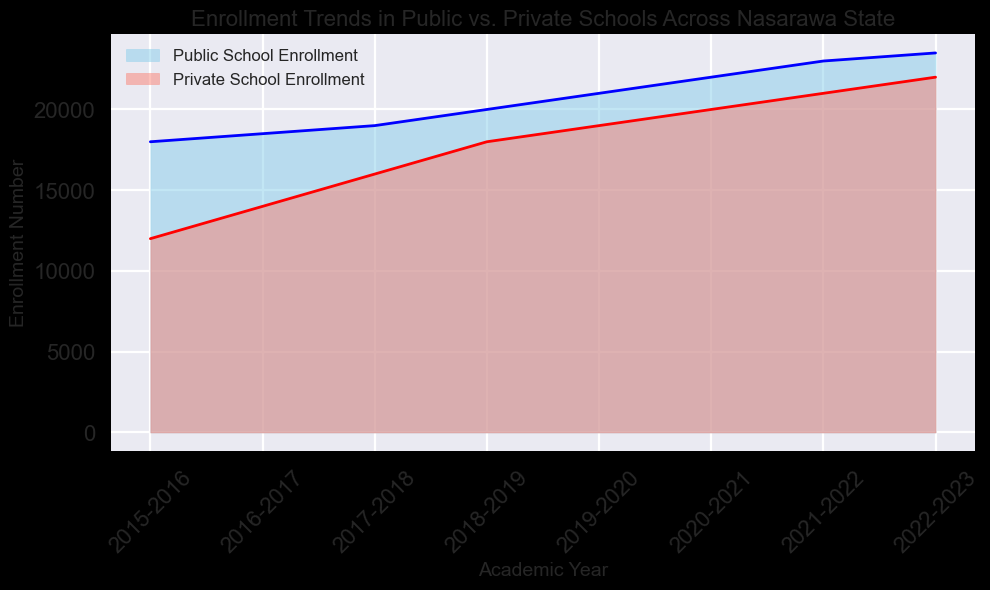What academic year shows the highest public school enrollment? By examining the line representing public school enrollment, the highest point is in the academic year 2022-2023.
Answer: 2022-2023 Which school type had a higher enrollment in the academic year 2018-2019? Compare the heights of the filled areas for both school types in 2018-2019. The blue area for public school enrollment is higher than the red area for private school enrollment.
Answer: Public School What’s the difference between public and private school enrollments in the academic year 2020-2021? Identify the enrollment numbers for 2020-2021: Public (22000) and Private (20000); then calculate the difference: 22000 - 20000 = 2000
Answer: 2000 How has the private school enrollment trend changed from 2015-2016 to 2022-2023? Observe the red line representing private school enrollment. It consistently increases every year from 12000 in 2015-2016 to 22000 in 2022-2023.
Answer: Consistently increased In which academic year did public and private school enrollments both increase by at least 1000 compared to the previous year? Look for years where enrollment increases by at least 1000. In 2018-2019, public school enrollment increased by 1000 (20000 - 19000) and private school enrollment increased by 2000 (18000 - 16000).
Answer: 2018-2019 What is the average public school enrollment from 2015-2016 to 2022-2023? Add the public school enrollments for each year: 18000+18500+19000+20000+21000+22000+23000+23500 = 165000, then divide by the number of years (8): 165000 / 8 = 20625
Answer: 20625 Which academic year had the smallest enrollment difference between public and private schools? Calculate the differences for each year: 2015-2016 (6000), 2016-2017 (4500), 2017-2018 (3000), 2018-2019 (2000), 2019-2020 (2000), 2020-2021 (2000), 2021-2022 (2000), 2022-2023 (1500). The smallest difference is in 2022-2023.
Answer: 2022-2023 Compare the enrollment trend slopes between public and private schools. Visually estimate the steepness of the lines. Both lines have a consistent upward trajectory, but the private school enrollment line (red) has a slightly steeper slope, indicating faster growth.
Answer: Private schools have a steeper trend What’s the total combined enrollment for public and private schools in the academic year 2021-2022? Add the enrollment numbers for both school types in 2021-2022: Public (23000) + Private (21000) = 44000
Answer: 44000 In which year did private school enrollment surpass 20000? Identify the year where the red line representing private school enrollment first reaches or exceeds 20000, which is in 2020-2021.
Answer: 2020-2021 